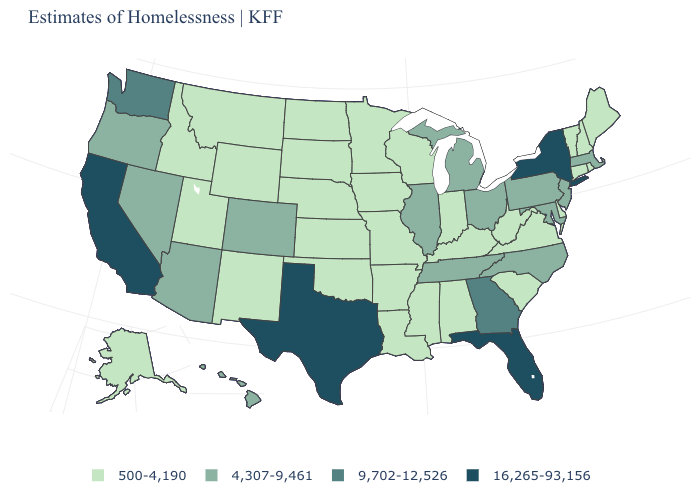What is the value of Maryland?
Short answer required. 4,307-9,461. What is the value of Oklahoma?
Keep it brief. 500-4,190. Which states have the lowest value in the USA?
Write a very short answer. Alabama, Alaska, Arkansas, Connecticut, Delaware, Idaho, Indiana, Iowa, Kansas, Kentucky, Louisiana, Maine, Minnesota, Mississippi, Missouri, Montana, Nebraska, New Hampshire, New Mexico, North Dakota, Oklahoma, Rhode Island, South Carolina, South Dakota, Utah, Vermont, Virginia, West Virginia, Wisconsin, Wyoming. Is the legend a continuous bar?
Keep it brief. No. What is the lowest value in the USA?
Write a very short answer. 500-4,190. Name the states that have a value in the range 9,702-12,526?
Be succinct. Georgia, Washington. What is the value of Nevada?
Answer briefly. 4,307-9,461. Name the states that have a value in the range 4,307-9,461?
Give a very brief answer. Arizona, Colorado, Hawaii, Illinois, Maryland, Massachusetts, Michigan, Nevada, New Jersey, North Carolina, Ohio, Oregon, Pennsylvania, Tennessee. Name the states that have a value in the range 16,265-93,156?
Concise answer only. California, Florida, New York, Texas. Does Minnesota have the highest value in the MidWest?
Give a very brief answer. No. Does New York have the highest value in the Northeast?
Answer briefly. Yes. What is the value of Ohio?
Give a very brief answer. 4,307-9,461. Name the states that have a value in the range 9,702-12,526?
Write a very short answer. Georgia, Washington. Is the legend a continuous bar?
Short answer required. No. What is the value of Oregon?
Short answer required. 4,307-9,461. 